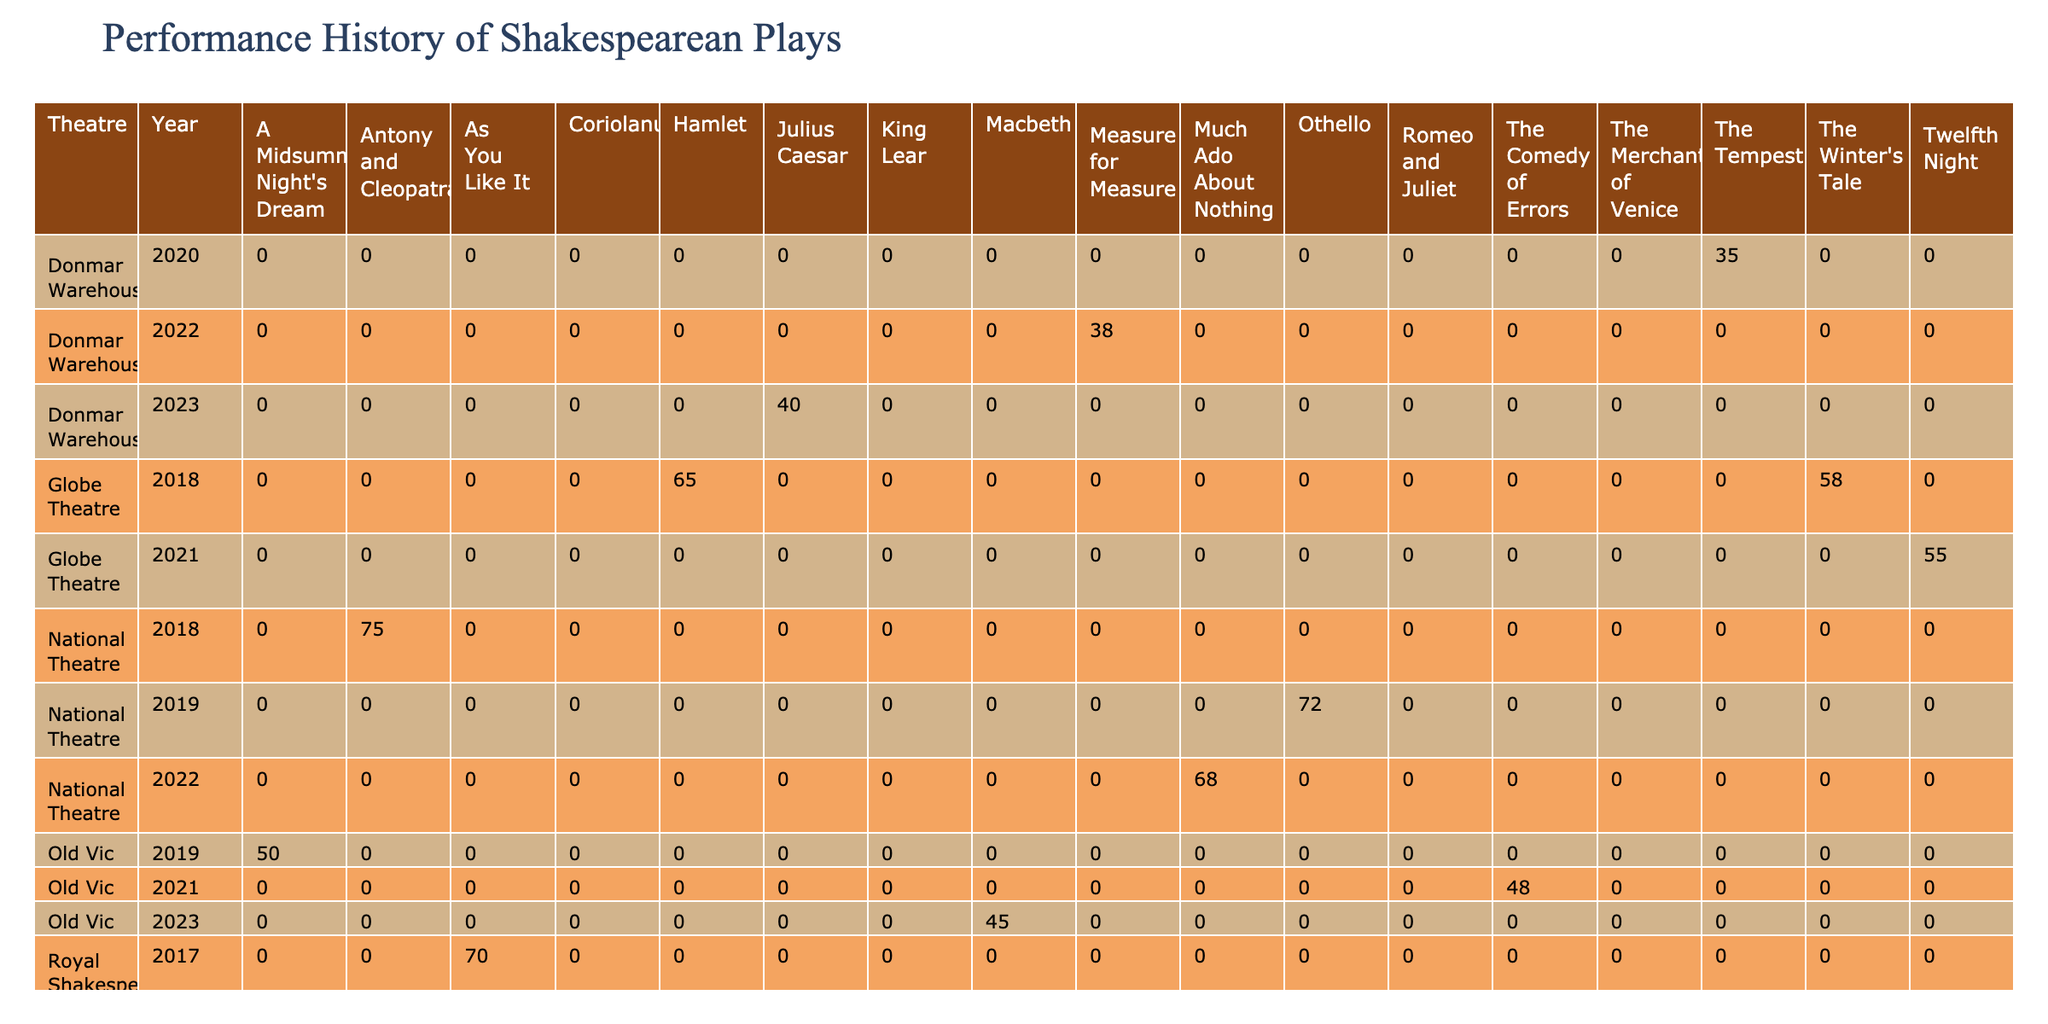What is the total number of performances of "Macbeth"? Looking at the table, there are two entries for "Macbeth": one in 2018 with 87 performances and another in 2023 with 45 performances. Therefore, the total is 87 + 45 = 132 performances.
Answer: 132 Which play had the highest average ticket price, and what was that price? The table shows the average ticket prices for various plays. Among them, "Julius Caesar" from Donmar Warehouse in 2023 has the highest price at £62.
Answer: £62 In which year did the "Royal Shakespeare Company" perform "As You Like It"? The table indicates that "As You Like It" was performed by the Royal Shakespeare Company in 2017, as it lists this play alongside the corresponding theatre and year.
Answer: 2017 What is the total audience for all performances of "Twelfth Night"? The table lists "Twelfth Night" with a single entry in 2021 that had an audience of 33,000. Therefore, the total audience for performances of this play is simply 33,000.
Answer: 33000 Did "Much Ado About Nothing" have more performances than "The Tempest"? "Much Ado About Nothing", performed in 2022, had 68 performances whereas "The Tempest", performed in 2020, had 35 performances. Since 68 is greater than 35, the answer is yes, it had more performances.
Answer: Yes What is the average number of performances for all plays at the Globe Theatre? The Globe Theatre has two performances listed: "Hamlet" with 65 performances in 2018 and "Twelfth Night" with 55 performances in 2021. Adding them gives 65 + 55 = 120, and averaging across the two gives 120/2 = 60 performances.
Answer: 60 Which actor led the performance of "Othello" and in what year was it performed? The table indicates that "Othello" was performed in 2019 with Adrian Lester as the lead actor. This specific data can be easily located in the table.
Answer: Adrian Lester, 2019 How many performances did "A Midsummer Night's Dream" have compared to "King Lear"? The table shows "A Midsummer Night's Dream" with 50 performances in 2019, while "King Lear" had 58 performances in the same year. Comparing these gives 50 for "A Midsummer Night's Dream" and 58 for "King Lear", showing that "King Lear" had more performances by a difference of 8.
Answer: King Lear had 8 more performances What percentage of the total audience for "Antony and Cleopatra" was achieved by the Royal Shakespeare Company’s "Macbeth"? "Antony and Cleopatra" had a total audience of 45,000 and "Macbeth" had a total audience of 52,200. To find the percentage, divide the audience for "Macbeth" by the audience for "Antony and Cleopatra": (52,200 / 45,000) * 100 = 116%. This means "Macbeth" attracted 116% of the audience of "Antony and Cleopatra".
Answer: 116% 